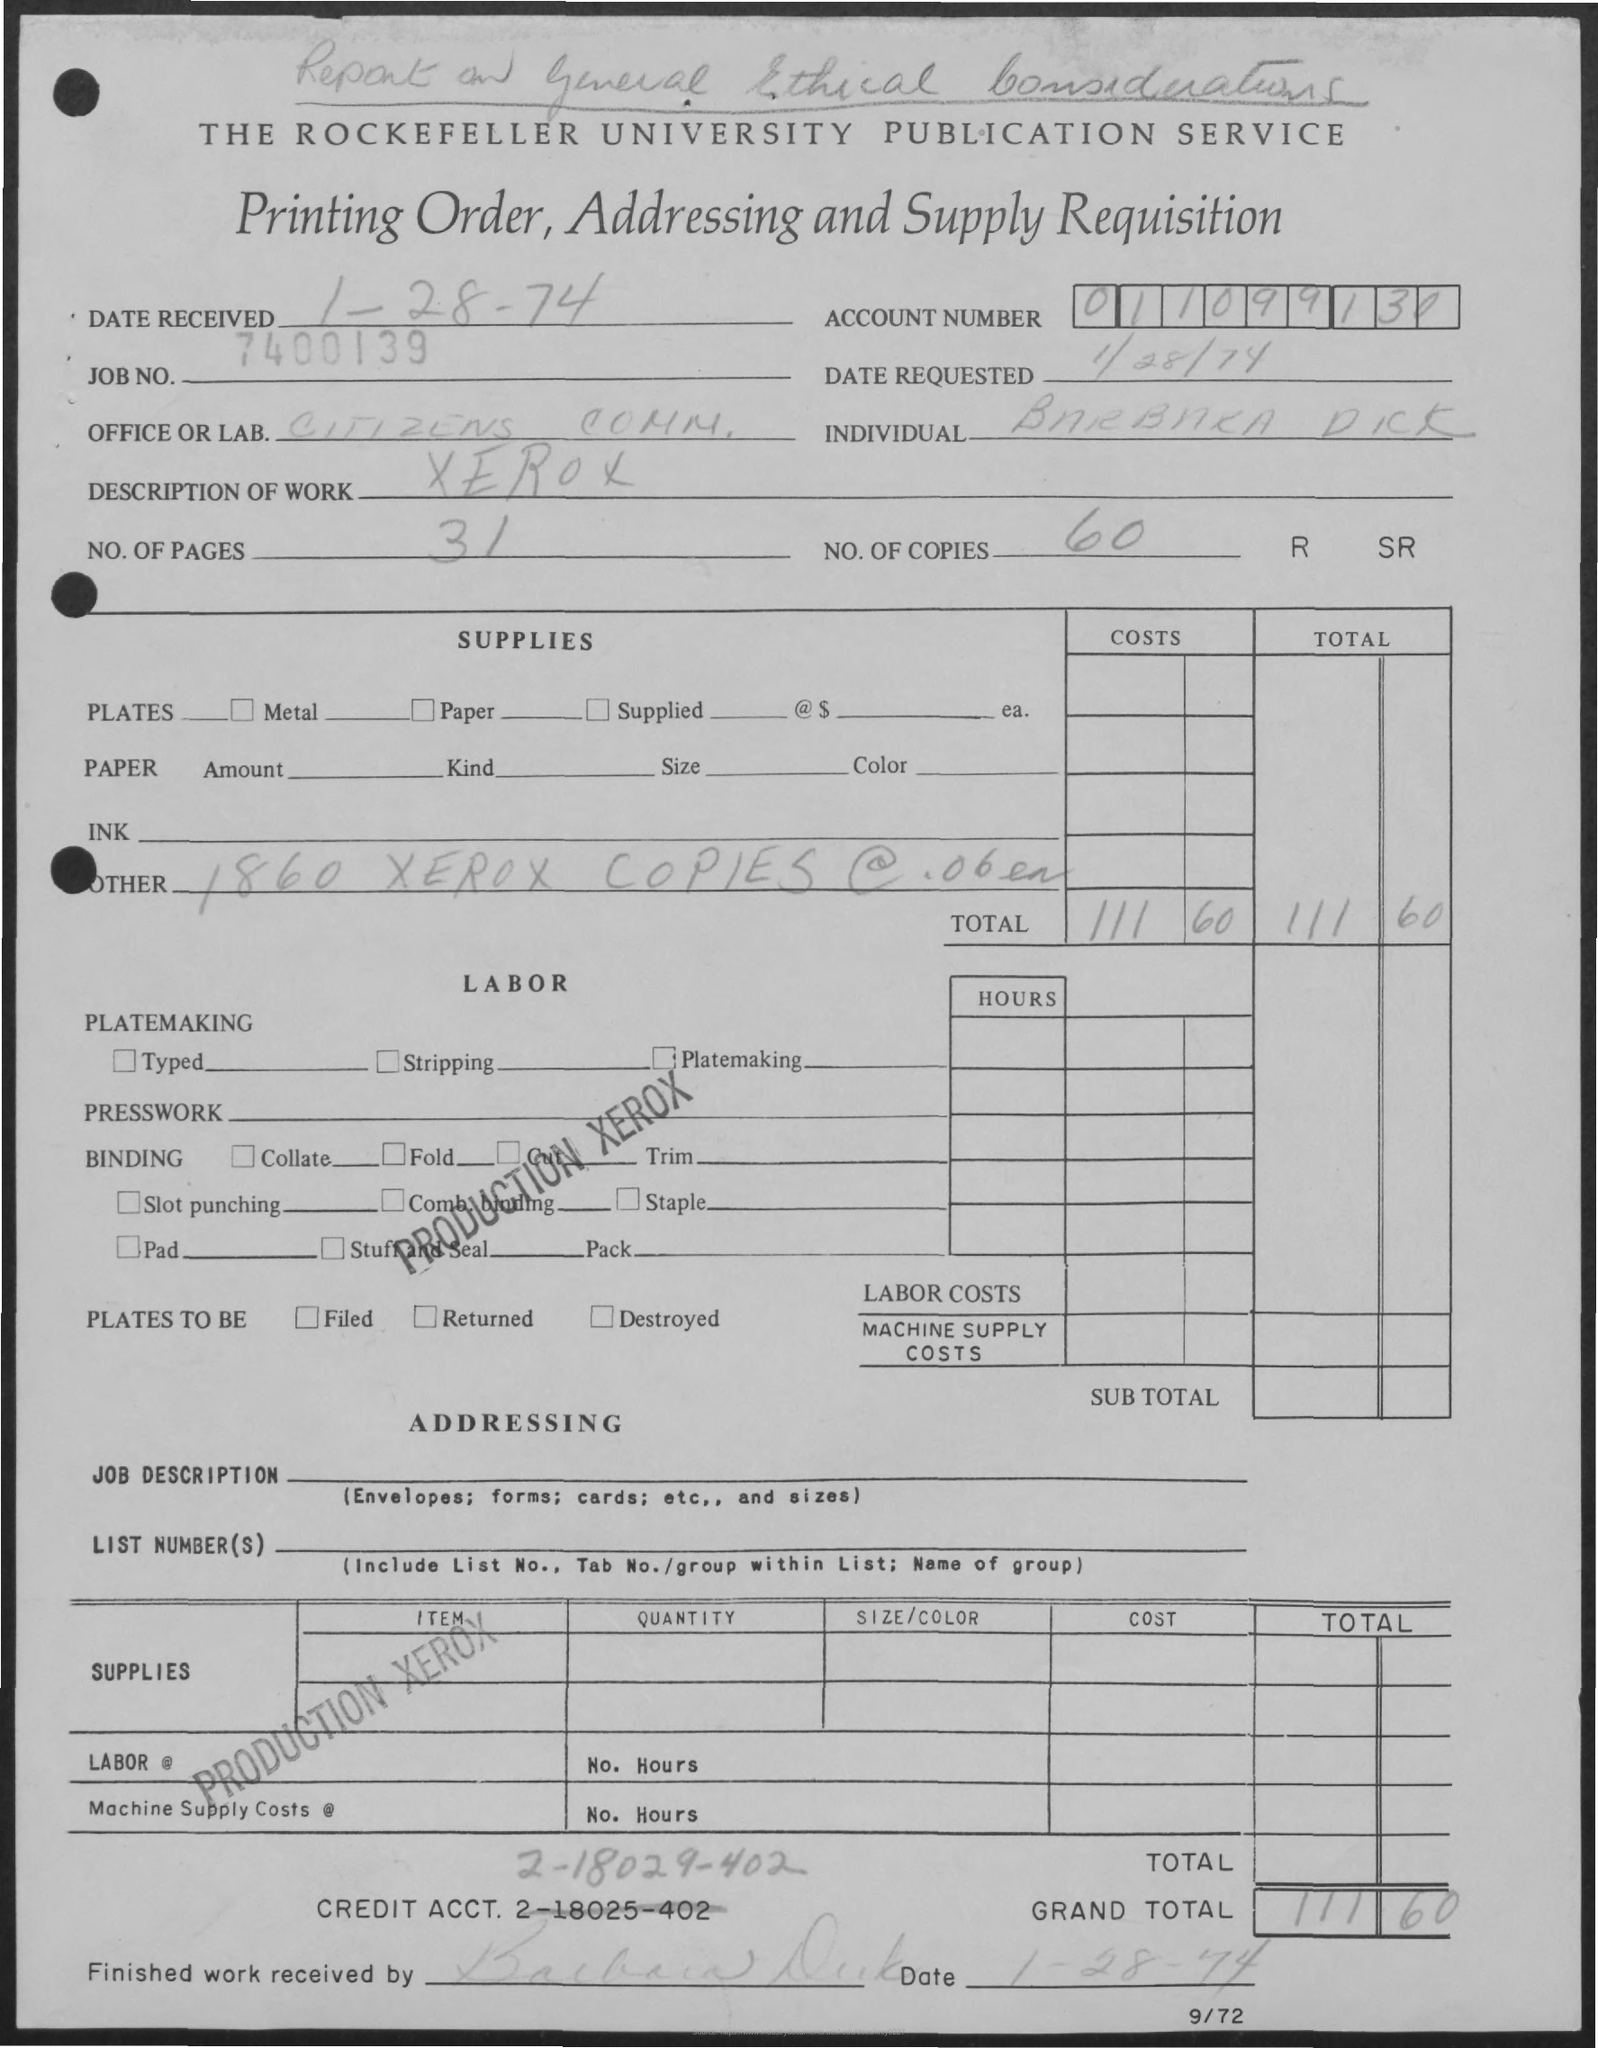What is the Job No.?
 7400139 